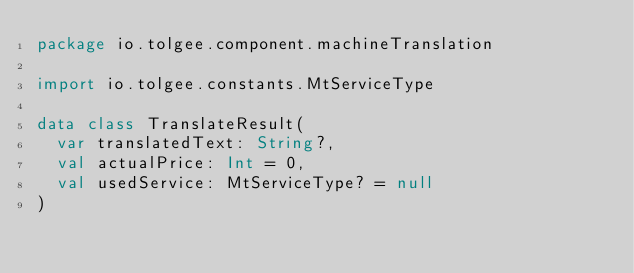Convert code to text. <code><loc_0><loc_0><loc_500><loc_500><_Kotlin_>package io.tolgee.component.machineTranslation

import io.tolgee.constants.MtServiceType

data class TranslateResult(
  var translatedText: String?,
  val actualPrice: Int = 0,
  val usedService: MtServiceType? = null
)
</code> 